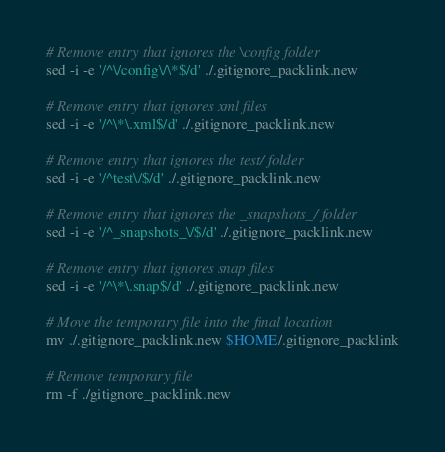<code> <loc_0><loc_0><loc_500><loc_500><_Bash_>
# Remove entry that ignores the \config folder
sed -i -e '/^\/config\/\*$/d' ./.gitignore_packlink.new

# Remove entry that ignores xml files
sed -i -e '/^\*\.xml$/d' ./.gitignore_packlink.new

# Remove entry that ignores the test/ folder
sed -i -e '/^test\/$/d' ./.gitignore_packlink.new

# Remove entry that ignores the _snapshots_/ folder
sed -i -e '/^_snapshots_\/$/d' ./.gitignore_packlink.new

# Remove entry that ignores snap files
sed -i -e '/^\*\.snap$/d' ./.gitignore_packlink.new

# Move the temporary file into the final location
mv ./.gitignore_packlink.new $HOME/.gitignore_packlink

# Remove temporary file
rm -f ./gitignore_packlink.new
</code> 